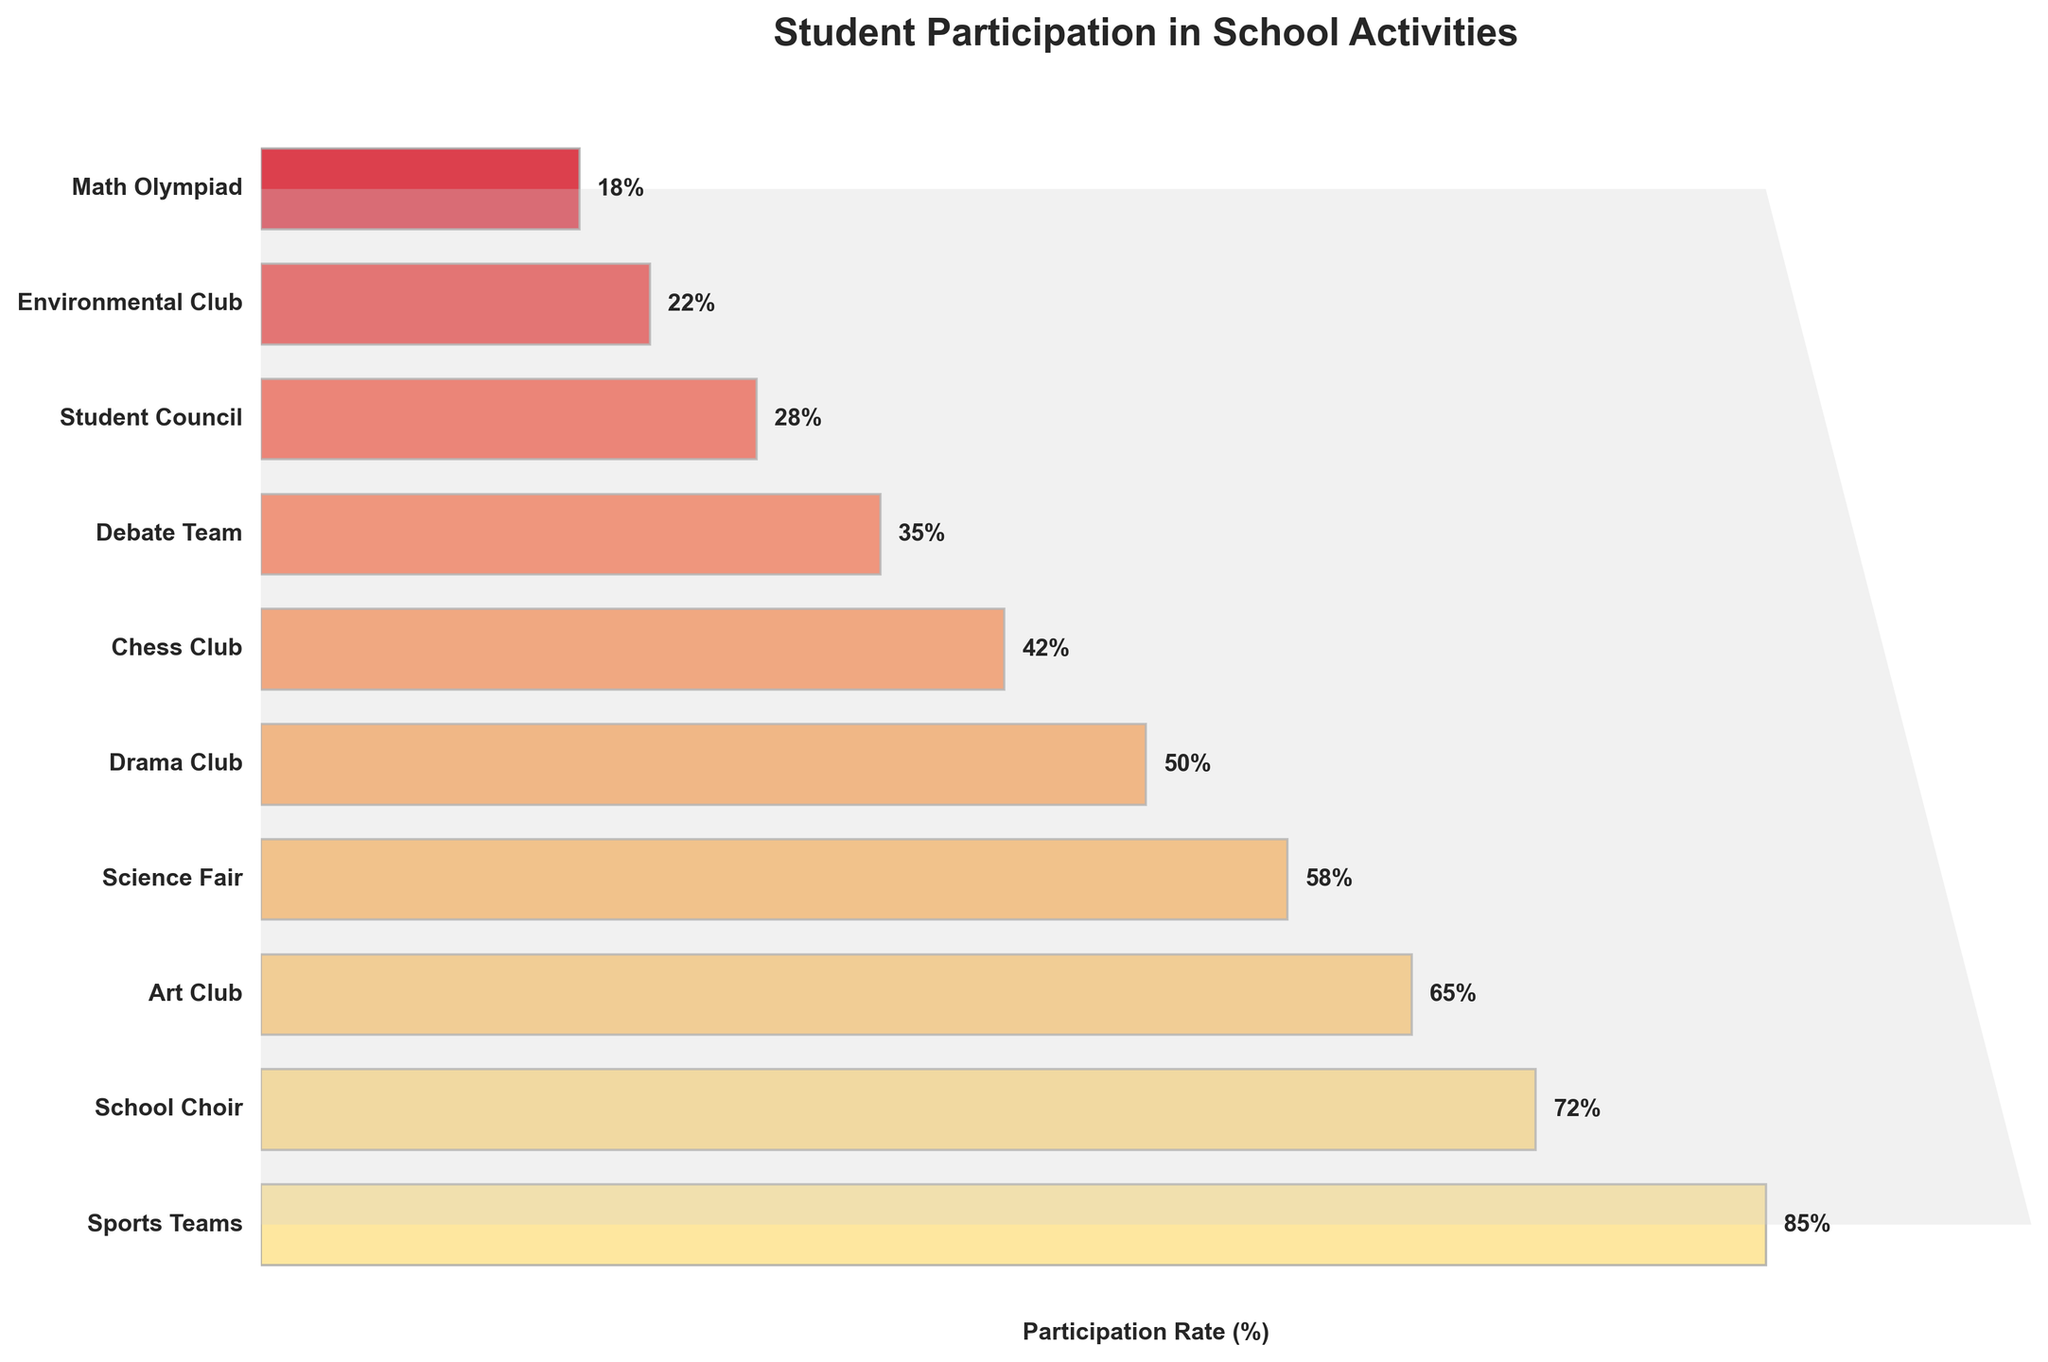What's the most popular school activity? The most popular school activity is the one with the highest participation rate. By looking at the funnel chart, "Sports Teams" has the highest percentage of 85%.
Answer: Sports Teams What is the participation rate for the Drama Club? By locating "Drama Club" on the chart, the participation rate shown next to it is 50%.
Answer: 50% How many more students participate in the School Choir compared to the Chess Club? The School Choir has a participation rate of 72%, while the Chess Club has 42%. The difference is 72% - 42% = 30%.
Answer: 30% Which activity has the lowest participation rate? The activity at the bottom of the funnel chart with the smallest percentage is "Math Olympiad" at 18%.
Answer: Math Olympiad What is the participation rate for the Science Fair? Look for "Science Fair" on the chart and note the participation rate mentioned next to it, which is 58%.
Answer: 58% If you combine the participation rates of the Student Council and the Environmental Club, what is the total? The participation rate for the Student Council is 28%, and for the Environmental Club is 22%. Adding these rates together: 28% + 22% = 50%.
Answer: 50% Which has a higher participation rate, Art Club or Drama Club, and by how much? The Art Club has a participation rate of 65%, while the Drama Club has 50%. The difference is 65% - 50% = 15%.
Answer: Art Club by 15% What does the polygon added to the chart represent? The polygon in light gray overlays the bars to represent the funnel shape, emphasizing the decreasing trend in activity participation as you go from the most to the least popular activities.
Answer: Funnel Shape How many activities have a participation rate of 50% or higher? Activities with 50% or higher participation are: Sports Teams, School Choir, Art Club, Science Fair, and Drama Club. Counting these gives a total of 5 activities.
Answer: 5 Is the participation in the Science Fair more or less than twice the participation in the Math Olympiad? The participation rate for the Science Fair is 58%, and for the Math Olympiad is 18%. Twice the Math Olympiad rate is 18% * 2 = 36%. Since 58% is greater than 36%, the Science Fair participation is more than twice.
Answer: More 